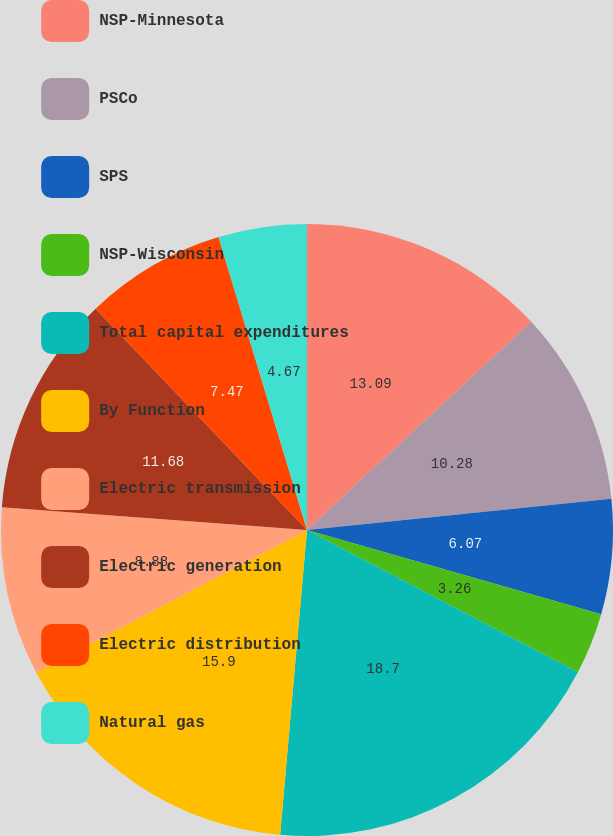Convert chart. <chart><loc_0><loc_0><loc_500><loc_500><pie_chart><fcel>NSP-Minnesota<fcel>PSCo<fcel>SPS<fcel>NSP-Wisconsin<fcel>Total capital expenditures<fcel>By Function<fcel>Electric transmission<fcel>Electric generation<fcel>Electric distribution<fcel>Natural gas<nl><fcel>13.09%<fcel>10.28%<fcel>6.07%<fcel>3.26%<fcel>18.7%<fcel>15.9%<fcel>8.88%<fcel>11.68%<fcel>7.47%<fcel>4.67%<nl></chart> 